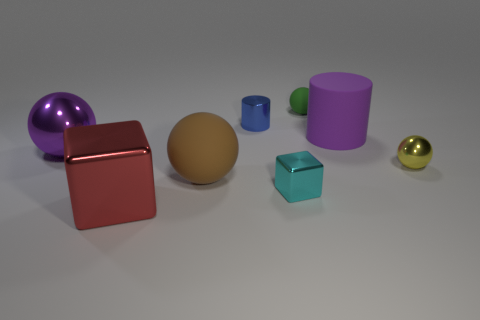Subtract all brown spheres. How many spheres are left? 3 Subtract 2 balls. How many balls are left? 2 Subtract all green spheres. How many spheres are left? 3 Add 1 balls. How many objects exist? 9 Subtract all red balls. Subtract all yellow cubes. How many balls are left? 4 Subtract all cylinders. How many objects are left? 6 Add 8 big brown rubber balls. How many big brown rubber balls exist? 9 Subtract 1 purple balls. How many objects are left? 7 Subtract all metal things. Subtract all big brown rubber objects. How many objects are left? 2 Add 5 tiny green objects. How many tiny green objects are left? 6 